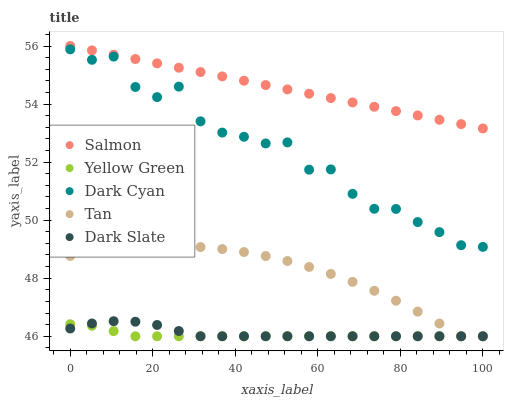Does Yellow Green have the minimum area under the curve?
Answer yes or no. Yes. Does Salmon have the maximum area under the curve?
Answer yes or no. Yes. Does Dark Slate have the minimum area under the curve?
Answer yes or no. No. Does Dark Slate have the maximum area under the curve?
Answer yes or no. No. Is Salmon the smoothest?
Answer yes or no. Yes. Is Dark Cyan the roughest?
Answer yes or no. Yes. Is Dark Slate the smoothest?
Answer yes or no. No. Is Dark Slate the roughest?
Answer yes or no. No. Does Dark Slate have the lowest value?
Answer yes or no. Yes. Does Salmon have the lowest value?
Answer yes or no. No. Does Salmon have the highest value?
Answer yes or no. Yes. Does Dark Slate have the highest value?
Answer yes or no. No. Is Dark Slate less than Salmon?
Answer yes or no. Yes. Is Salmon greater than Tan?
Answer yes or no. Yes. Does Yellow Green intersect Tan?
Answer yes or no. Yes. Is Yellow Green less than Tan?
Answer yes or no. No. Is Yellow Green greater than Tan?
Answer yes or no. No. Does Dark Slate intersect Salmon?
Answer yes or no. No. 